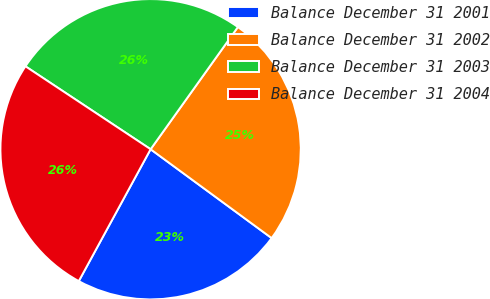Convert chart. <chart><loc_0><loc_0><loc_500><loc_500><pie_chart><fcel>Balance December 31 2001<fcel>Balance December 31 2002<fcel>Balance December 31 2003<fcel>Balance December 31 2004<nl><fcel>22.86%<fcel>25.21%<fcel>25.56%<fcel>26.38%<nl></chart> 